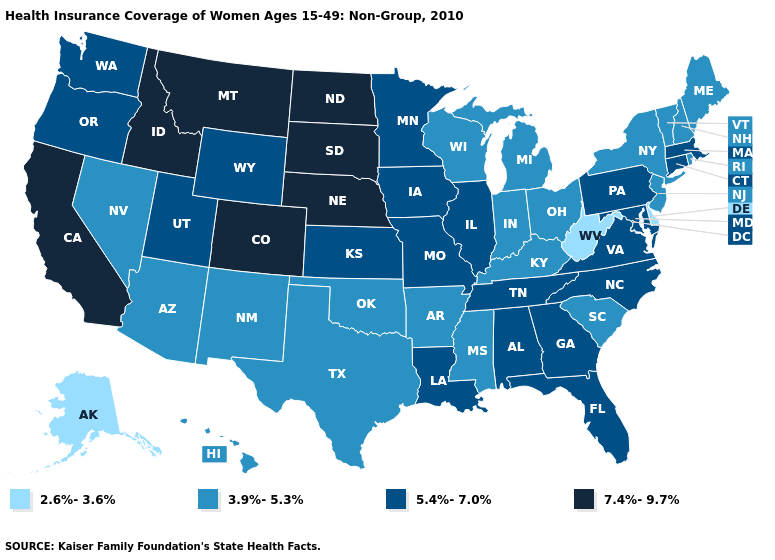Does Nebraska have the same value as Pennsylvania?
Answer briefly. No. What is the highest value in states that border Oregon?
Short answer required. 7.4%-9.7%. What is the value of Washington?
Keep it brief. 5.4%-7.0%. Name the states that have a value in the range 7.4%-9.7%?
Write a very short answer. California, Colorado, Idaho, Montana, Nebraska, North Dakota, South Dakota. What is the lowest value in the Northeast?
Write a very short answer. 3.9%-5.3%. Does Washington have the lowest value in the USA?
Concise answer only. No. What is the highest value in the USA?
Short answer required. 7.4%-9.7%. Does Missouri have the highest value in the MidWest?
Concise answer only. No. Is the legend a continuous bar?
Be succinct. No. What is the highest value in the West ?
Concise answer only. 7.4%-9.7%. Among the states that border Tennessee , does Missouri have the highest value?
Concise answer only. Yes. What is the value of Kentucky?
Give a very brief answer. 3.9%-5.3%. What is the lowest value in the USA?
Short answer required. 2.6%-3.6%. What is the value of Utah?
Be succinct. 5.4%-7.0%. Does California have the highest value in the USA?
Answer briefly. Yes. 